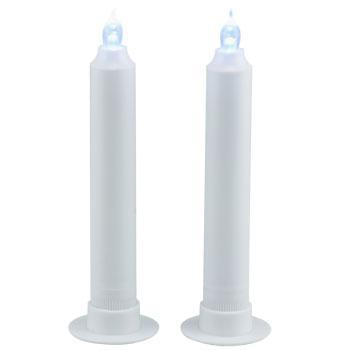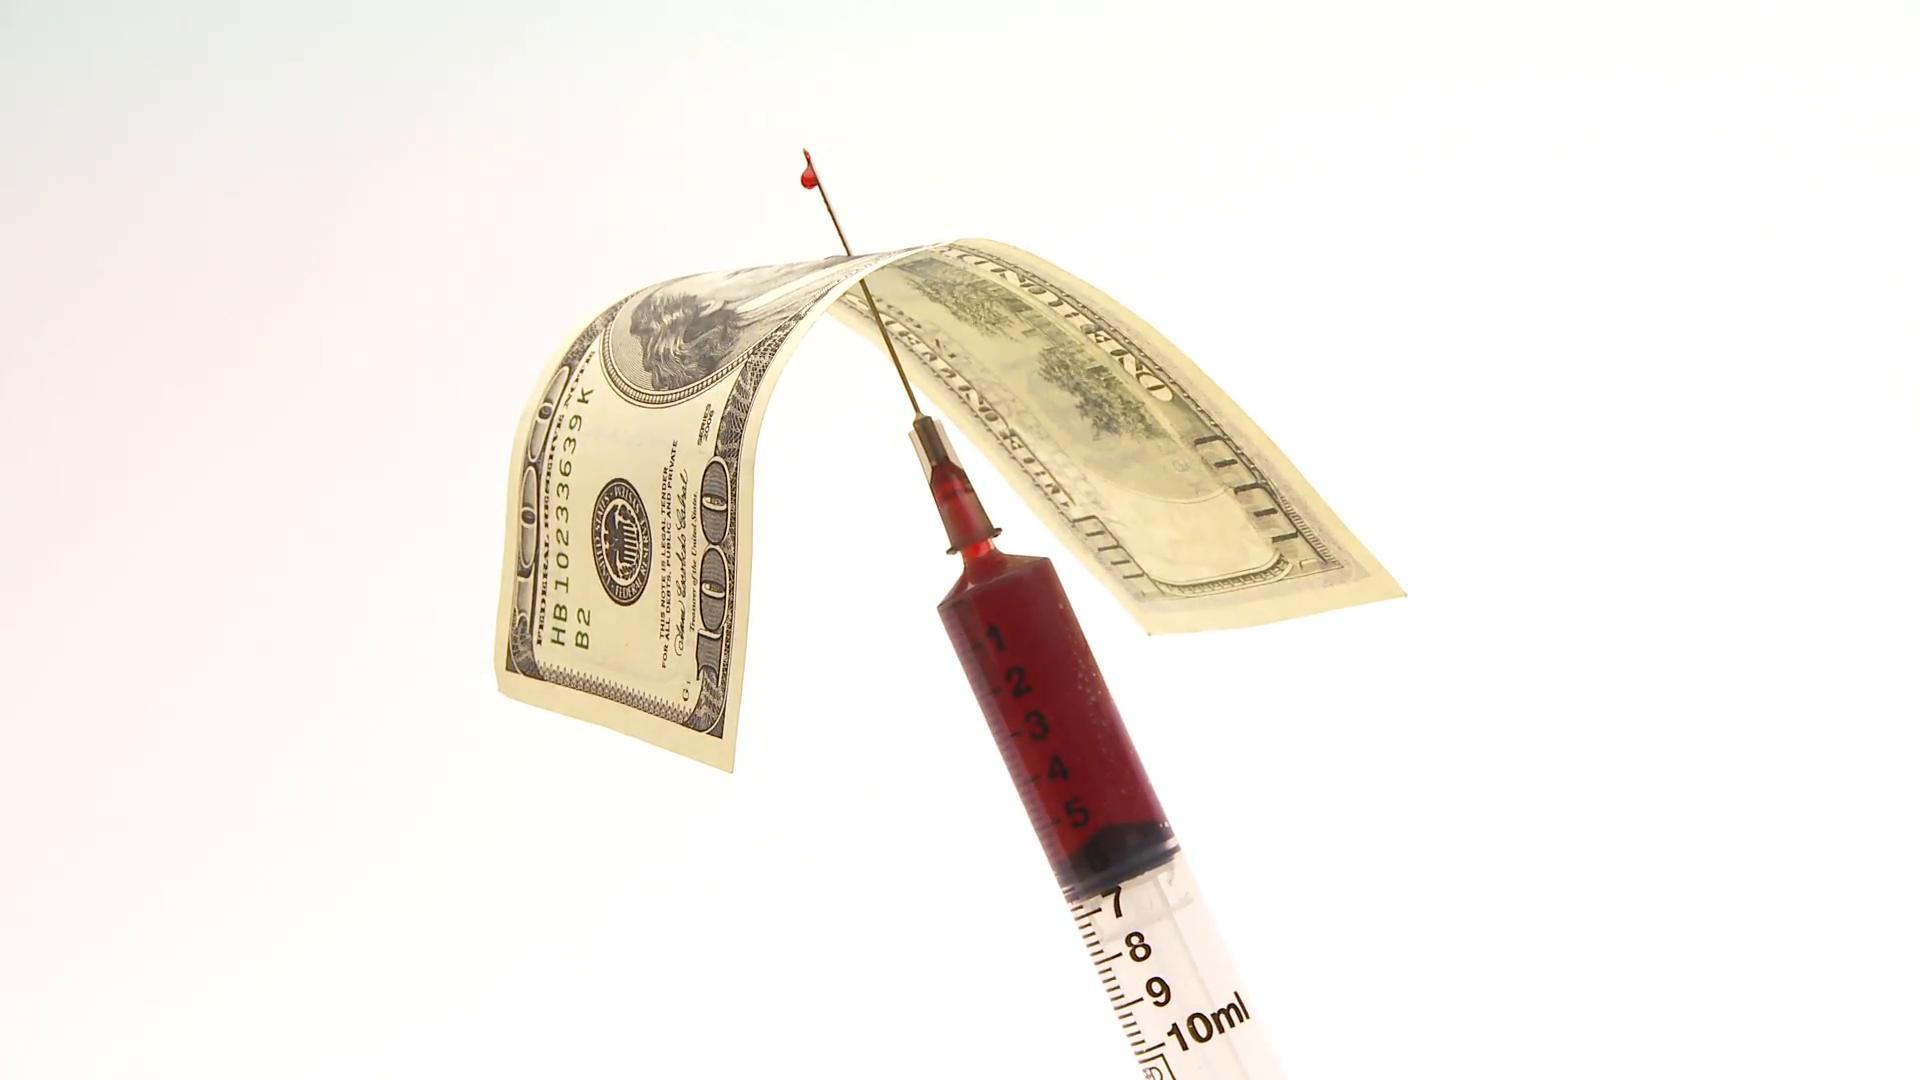The first image is the image on the left, the second image is the image on the right. Evaluate the accuracy of this statement regarding the images: "American money is visible in one of the images.". Is it true? Answer yes or no. Yes. The first image is the image on the left, the second image is the image on the right. Assess this claim about the two images: "The right image contains paper money and a syringe.". Correct or not? Answer yes or no. Yes. 